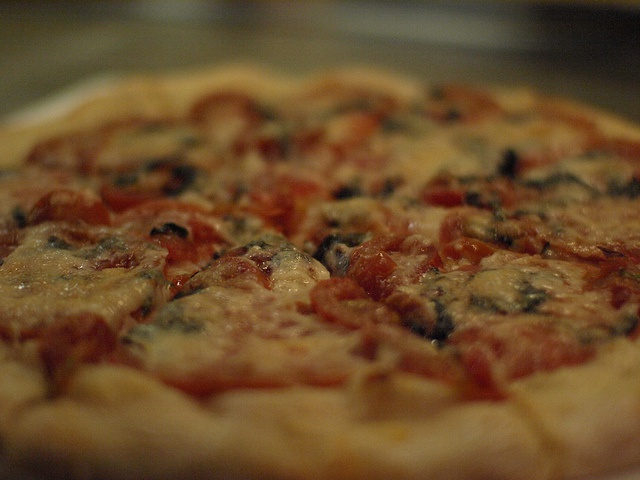Describe the objects in this image and their specific colors. I can see pizza in maroon, black, and olive tones and pizza in black, maroon, and olive tones in this image. 